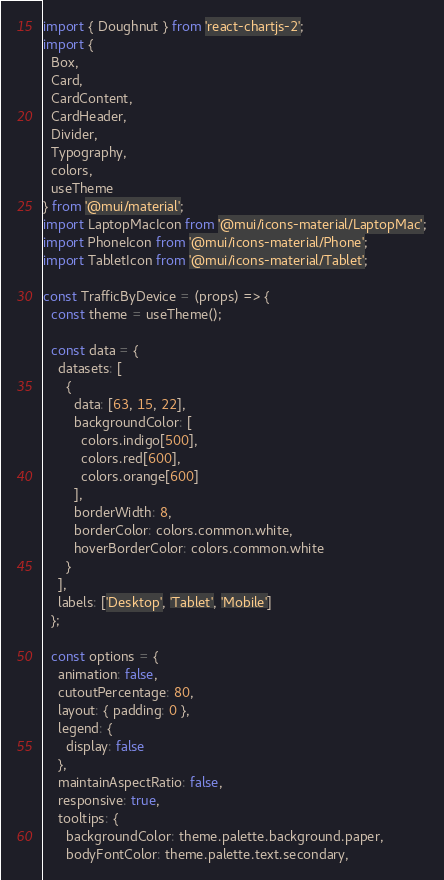<code> <loc_0><loc_0><loc_500><loc_500><_JavaScript_>import { Doughnut } from 'react-chartjs-2';
import {
  Box,
  Card,
  CardContent,
  CardHeader,
  Divider,
  Typography,
  colors,
  useTheme
} from '@mui/material';
import LaptopMacIcon from '@mui/icons-material/LaptopMac';
import PhoneIcon from '@mui/icons-material/Phone';
import TabletIcon from '@mui/icons-material/Tablet';

const TrafficByDevice = (props) => {
  const theme = useTheme();

  const data = {
    datasets: [
      {
        data: [63, 15, 22],
        backgroundColor: [
          colors.indigo[500],
          colors.red[600],
          colors.orange[600]
        ],
        borderWidth: 8,
        borderColor: colors.common.white,
        hoverBorderColor: colors.common.white
      }
    ],
    labels: ['Desktop', 'Tablet', 'Mobile']
  };

  const options = {
    animation: false,
    cutoutPercentage: 80,
    layout: { padding: 0 },
    legend: {
      display: false
    },
    maintainAspectRatio: false,
    responsive: true,
    tooltips: {
      backgroundColor: theme.palette.background.paper,
      bodyFontColor: theme.palette.text.secondary,</code> 